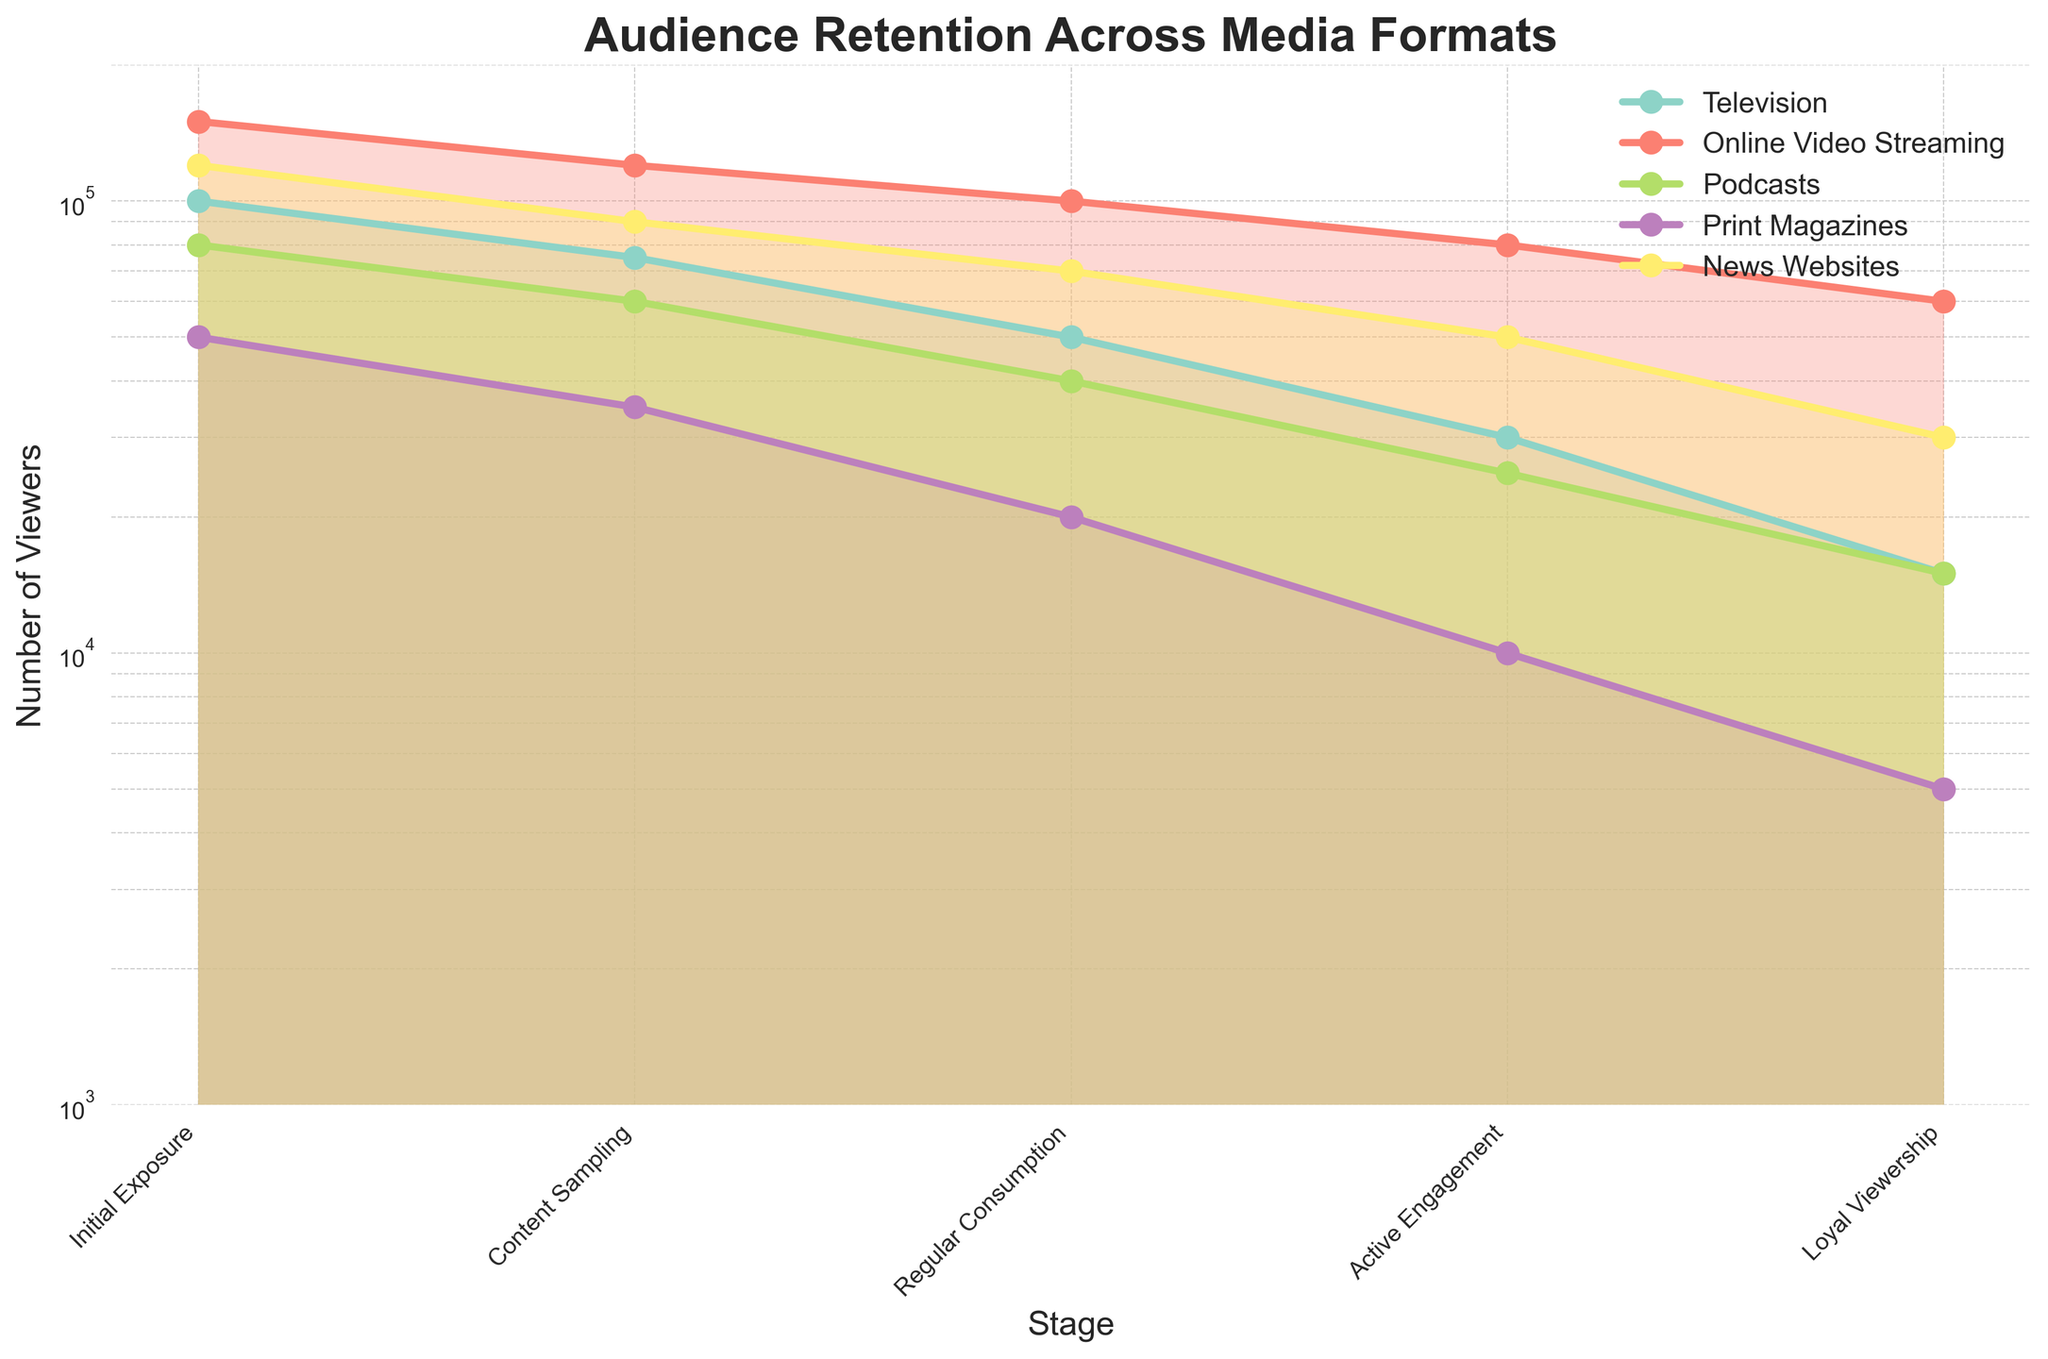Question: What is the title of the figure? Explanation: The title is typically displayed at the top of the figure, indicating the main focus or subject of the visual data representation.
Answer: Audience Retention Across Media Formats Question: How many stages of audience retention are shown? Explanation: To answer, count the number of distinct labels on the x-axis representing different stages of audience retention.
Answer: 5 Question: Which media format has the highest initial exposure? Explanation: Look at the initial values (first point on the x-axis) for each media type and identify the highest value among them.
Answer: Online Video Streaming Question: At the Loyal Viewership stage, which media format has the second-highest number of viewers? Explanation: Check the final values (last point on the x-axis) for each media type and identify the second highest value among them.
Answer: News Websites Question: Which stage shows the largest drop in audience retention for Print Magazines? Explanation: Compare the drop in the number of viewers between consecutive stages for Print Magazines and identify which transition has the largest decrement.
Answer: Active Engagement Question: What is the difference in loyal viewership between Online Video Streaming and Podcasts? Explanation: Subtract the loyal viewership value of Podcasts from that of Online Video Streaming to find the difference.
Answer: 45000 Question: At the Active Engagement stage, how do the number of viewers of News Websites compare to those of Online Video Streaming? Explanation: Compare the values at the Active Engagement stage for both News Websites and Online Video Streaming.
Answer: News Websites have fewer viewers Question: During the Content Sampling stage, which media format has the smallest audience? Explanation: Identify the smallest value at the Content Sampling stage by comparing all media formats.
Answer: Print Magazines Question: What is the average number of viewers for Television across all stages? Explanation: Sum the viewer numbers for Television across all stages and divide by the number of stages (5 in this case). The values are [100000, 75000, 50000, 30000, 15000]. Average = (100000 + 75000 + 50000 + 30000 + 15000) / 5 = 54000
Answer: 54000 